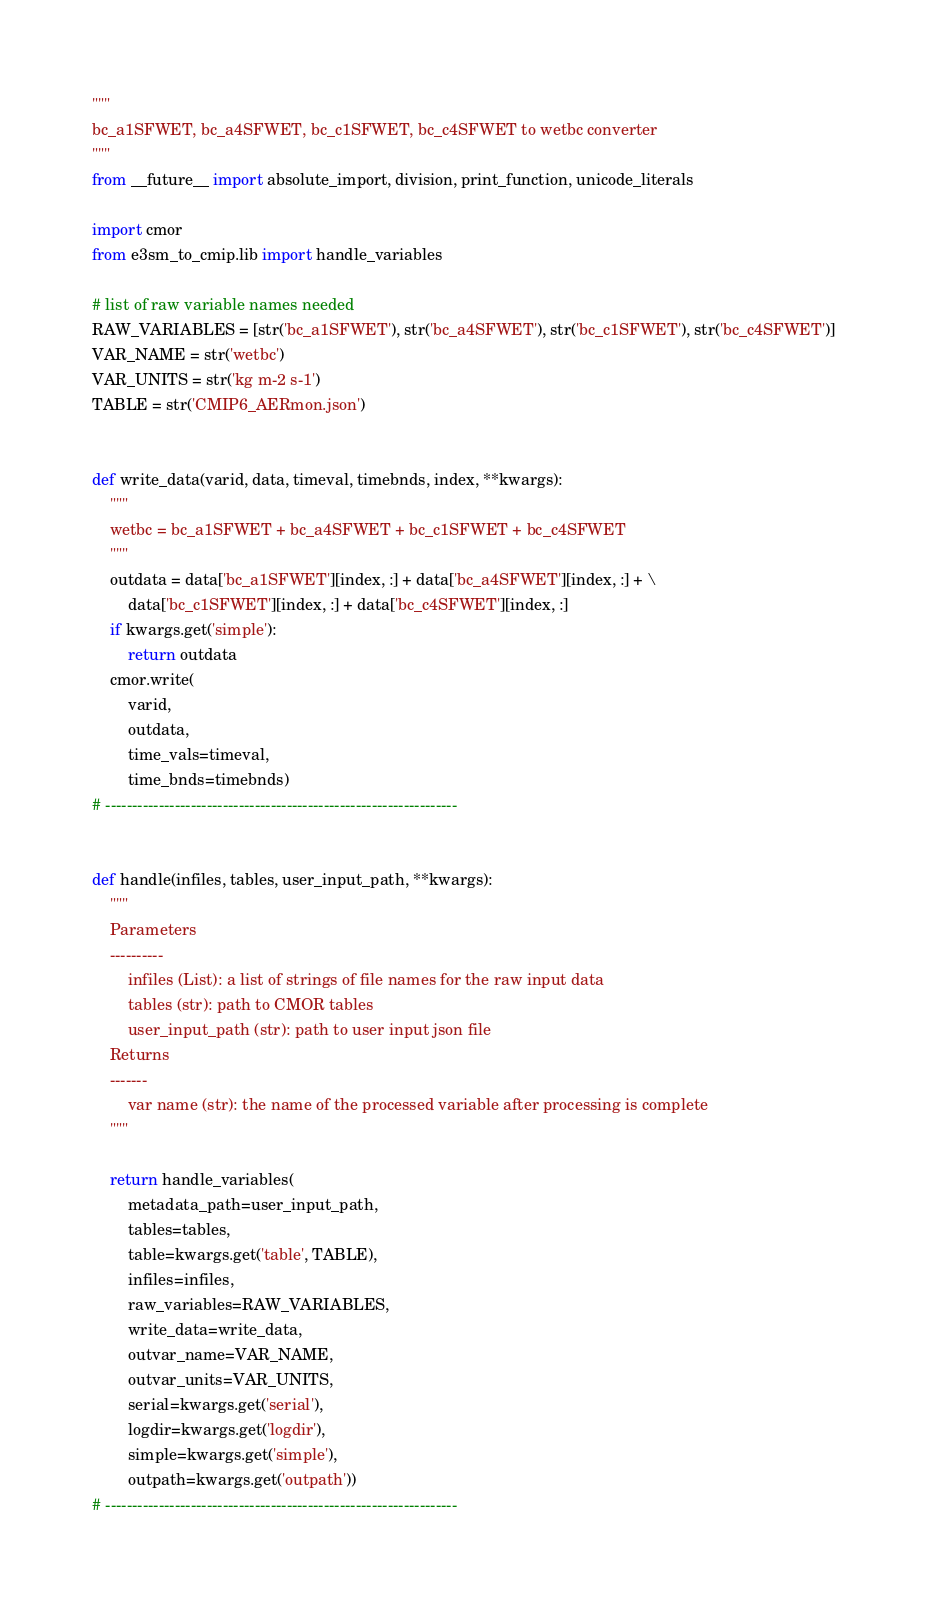<code> <loc_0><loc_0><loc_500><loc_500><_Python_>"""
bc_a1SFWET, bc_a4SFWET, bc_c1SFWET, bc_c4SFWET to wetbc converter
"""
from __future__ import absolute_import, division, print_function, unicode_literals

import cmor
from e3sm_to_cmip.lib import handle_variables

# list of raw variable names needed
RAW_VARIABLES = [str('bc_a1SFWET'), str('bc_a4SFWET'), str('bc_c1SFWET'), str('bc_c4SFWET')]
VAR_NAME = str('wetbc')
VAR_UNITS = str('kg m-2 s-1')
TABLE = str('CMIP6_AERmon.json')


def write_data(varid, data, timeval, timebnds, index, **kwargs):
    """
    wetbc = bc_a1SFWET + bc_a4SFWET + bc_c1SFWET + bc_c4SFWET
    """
    outdata = data['bc_a1SFWET'][index, :] + data['bc_a4SFWET'][index, :] + \
        data['bc_c1SFWET'][index, :] + data['bc_c4SFWET'][index, :]
    if kwargs.get('simple'):
        return outdata
    cmor.write(
        varid,
        outdata,
        time_vals=timeval,
        time_bnds=timebnds)
# ------------------------------------------------------------------


def handle(infiles, tables, user_input_path, **kwargs):
    """
    Parameters
    ----------
        infiles (List): a list of strings of file names for the raw input data
        tables (str): path to CMOR tables
        user_input_path (str): path to user input json file
    Returns
    -------
        var name (str): the name of the processed variable after processing is complete
    """

    return handle_variables(
        metadata_path=user_input_path,
        tables=tables,
        table=kwargs.get('table', TABLE),
        infiles=infiles,
        raw_variables=RAW_VARIABLES,
        write_data=write_data,
        outvar_name=VAR_NAME,
        outvar_units=VAR_UNITS,
        serial=kwargs.get('serial'),
        logdir=kwargs.get('logdir'),
        simple=kwargs.get('simple'),
        outpath=kwargs.get('outpath'))
# ------------------------------------------------------------------
</code> 